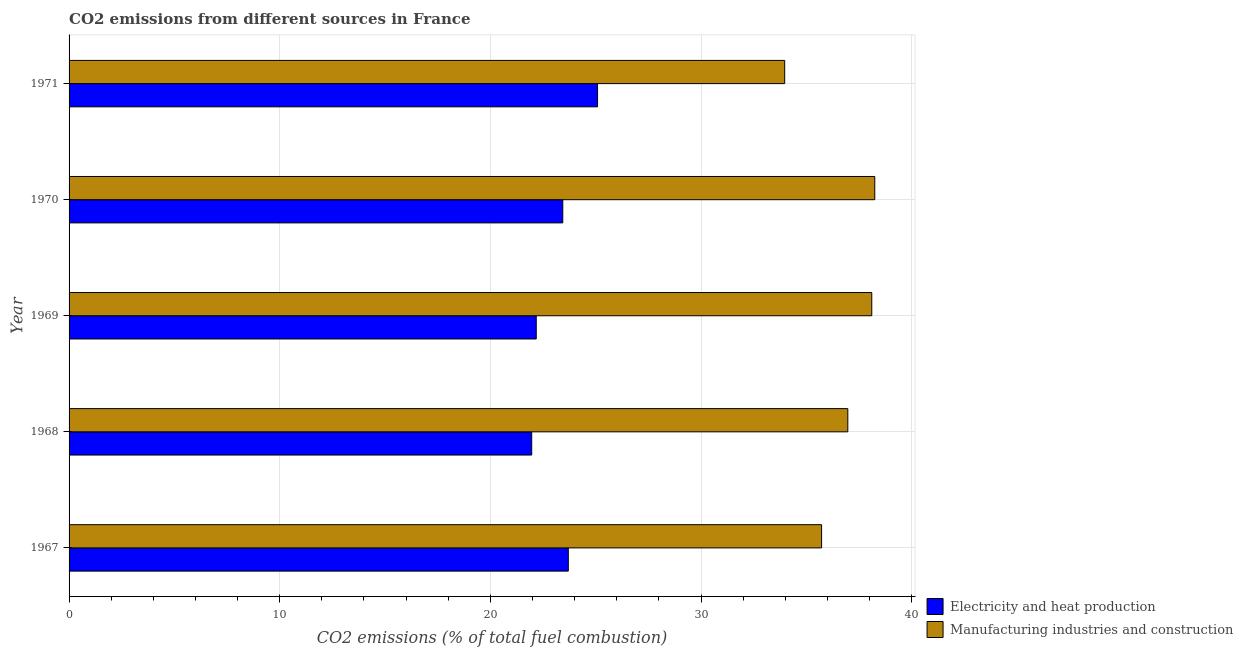How many different coloured bars are there?
Your response must be concise. 2. How many groups of bars are there?
Ensure brevity in your answer.  5. Are the number of bars on each tick of the Y-axis equal?
Your response must be concise. Yes. How many bars are there on the 2nd tick from the bottom?
Your answer should be very brief. 2. In how many cases, is the number of bars for a given year not equal to the number of legend labels?
Keep it short and to the point. 0. What is the co2 emissions due to manufacturing industries in 1969?
Make the answer very short. 38.1. Across all years, what is the maximum co2 emissions due to manufacturing industries?
Make the answer very short. 38.25. Across all years, what is the minimum co2 emissions due to manufacturing industries?
Ensure brevity in your answer.  33.97. In which year was the co2 emissions due to manufacturing industries maximum?
Offer a terse response. 1970. In which year was the co2 emissions due to electricity and heat production minimum?
Your answer should be compact. 1968. What is the total co2 emissions due to manufacturing industries in the graph?
Offer a very short reply. 183.02. What is the difference between the co2 emissions due to electricity and heat production in 1968 and that in 1970?
Keep it short and to the point. -1.48. What is the difference between the co2 emissions due to manufacturing industries in 1967 and the co2 emissions due to electricity and heat production in 1970?
Offer a very short reply. 12.29. What is the average co2 emissions due to manufacturing industries per year?
Offer a terse response. 36.6. In the year 1969, what is the difference between the co2 emissions due to manufacturing industries and co2 emissions due to electricity and heat production?
Your answer should be compact. 15.93. What is the ratio of the co2 emissions due to manufacturing industries in 1967 to that in 1971?
Keep it short and to the point. 1.05. Is the difference between the co2 emissions due to electricity and heat production in 1967 and 1969 greater than the difference between the co2 emissions due to manufacturing industries in 1967 and 1969?
Offer a very short reply. Yes. What is the difference between the highest and the second highest co2 emissions due to manufacturing industries?
Keep it short and to the point. 0.14. What is the difference between the highest and the lowest co2 emissions due to electricity and heat production?
Make the answer very short. 3.13. Is the sum of the co2 emissions due to manufacturing industries in 1968 and 1970 greater than the maximum co2 emissions due to electricity and heat production across all years?
Give a very brief answer. Yes. What does the 2nd bar from the top in 1970 represents?
Ensure brevity in your answer.  Electricity and heat production. What does the 1st bar from the bottom in 1967 represents?
Your answer should be compact. Electricity and heat production. What is the difference between two consecutive major ticks on the X-axis?
Make the answer very short. 10. Does the graph contain grids?
Provide a short and direct response. Yes. Where does the legend appear in the graph?
Make the answer very short. Bottom right. How many legend labels are there?
Offer a terse response. 2. How are the legend labels stacked?
Your answer should be very brief. Vertical. What is the title of the graph?
Your answer should be very brief. CO2 emissions from different sources in France. Does "RDB concessional" appear as one of the legend labels in the graph?
Offer a very short reply. No. What is the label or title of the X-axis?
Provide a succinct answer. CO2 emissions (% of total fuel combustion). What is the CO2 emissions (% of total fuel combustion) of Electricity and heat production in 1967?
Offer a terse response. 23.7. What is the CO2 emissions (% of total fuel combustion) in Manufacturing industries and construction in 1967?
Provide a succinct answer. 35.72. What is the CO2 emissions (% of total fuel combustion) of Electricity and heat production in 1968?
Provide a succinct answer. 21.96. What is the CO2 emissions (% of total fuel combustion) of Manufacturing industries and construction in 1968?
Your answer should be compact. 36.97. What is the CO2 emissions (% of total fuel combustion) of Electricity and heat production in 1969?
Provide a short and direct response. 22.18. What is the CO2 emissions (% of total fuel combustion) of Manufacturing industries and construction in 1969?
Offer a very short reply. 38.1. What is the CO2 emissions (% of total fuel combustion) in Electricity and heat production in 1970?
Provide a short and direct response. 23.44. What is the CO2 emissions (% of total fuel combustion) in Manufacturing industries and construction in 1970?
Your response must be concise. 38.25. What is the CO2 emissions (% of total fuel combustion) in Electricity and heat production in 1971?
Give a very brief answer. 25.09. What is the CO2 emissions (% of total fuel combustion) of Manufacturing industries and construction in 1971?
Provide a short and direct response. 33.97. Across all years, what is the maximum CO2 emissions (% of total fuel combustion) of Electricity and heat production?
Make the answer very short. 25.09. Across all years, what is the maximum CO2 emissions (% of total fuel combustion) of Manufacturing industries and construction?
Provide a short and direct response. 38.25. Across all years, what is the minimum CO2 emissions (% of total fuel combustion) of Electricity and heat production?
Offer a terse response. 21.96. Across all years, what is the minimum CO2 emissions (% of total fuel combustion) of Manufacturing industries and construction?
Your response must be concise. 33.97. What is the total CO2 emissions (% of total fuel combustion) of Electricity and heat production in the graph?
Provide a succinct answer. 116.36. What is the total CO2 emissions (% of total fuel combustion) of Manufacturing industries and construction in the graph?
Your answer should be compact. 183.02. What is the difference between the CO2 emissions (% of total fuel combustion) in Electricity and heat production in 1967 and that in 1968?
Offer a very short reply. 1.74. What is the difference between the CO2 emissions (% of total fuel combustion) of Manufacturing industries and construction in 1967 and that in 1968?
Your answer should be compact. -1.24. What is the difference between the CO2 emissions (% of total fuel combustion) of Electricity and heat production in 1967 and that in 1969?
Give a very brief answer. 1.52. What is the difference between the CO2 emissions (% of total fuel combustion) of Manufacturing industries and construction in 1967 and that in 1969?
Your answer should be very brief. -2.38. What is the difference between the CO2 emissions (% of total fuel combustion) in Electricity and heat production in 1967 and that in 1970?
Give a very brief answer. 0.26. What is the difference between the CO2 emissions (% of total fuel combustion) of Manufacturing industries and construction in 1967 and that in 1970?
Give a very brief answer. -2.52. What is the difference between the CO2 emissions (% of total fuel combustion) of Electricity and heat production in 1967 and that in 1971?
Provide a short and direct response. -1.39. What is the difference between the CO2 emissions (% of total fuel combustion) of Manufacturing industries and construction in 1967 and that in 1971?
Keep it short and to the point. 1.75. What is the difference between the CO2 emissions (% of total fuel combustion) in Electricity and heat production in 1968 and that in 1969?
Make the answer very short. -0.22. What is the difference between the CO2 emissions (% of total fuel combustion) of Manufacturing industries and construction in 1968 and that in 1969?
Your answer should be very brief. -1.14. What is the difference between the CO2 emissions (% of total fuel combustion) in Electricity and heat production in 1968 and that in 1970?
Provide a succinct answer. -1.48. What is the difference between the CO2 emissions (% of total fuel combustion) of Manufacturing industries and construction in 1968 and that in 1970?
Provide a succinct answer. -1.28. What is the difference between the CO2 emissions (% of total fuel combustion) of Electricity and heat production in 1968 and that in 1971?
Make the answer very short. -3.13. What is the difference between the CO2 emissions (% of total fuel combustion) of Manufacturing industries and construction in 1968 and that in 1971?
Give a very brief answer. 3. What is the difference between the CO2 emissions (% of total fuel combustion) in Electricity and heat production in 1969 and that in 1970?
Offer a very short reply. -1.26. What is the difference between the CO2 emissions (% of total fuel combustion) in Manufacturing industries and construction in 1969 and that in 1970?
Provide a short and direct response. -0.14. What is the difference between the CO2 emissions (% of total fuel combustion) of Electricity and heat production in 1969 and that in 1971?
Offer a terse response. -2.91. What is the difference between the CO2 emissions (% of total fuel combustion) in Manufacturing industries and construction in 1969 and that in 1971?
Keep it short and to the point. 4.13. What is the difference between the CO2 emissions (% of total fuel combustion) in Electricity and heat production in 1970 and that in 1971?
Your answer should be very brief. -1.65. What is the difference between the CO2 emissions (% of total fuel combustion) of Manufacturing industries and construction in 1970 and that in 1971?
Your answer should be compact. 4.28. What is the difference between the CO2 emissions (% of total fuel combustion) in Electricity and heat production in 1967 and the CO2 emissions (% of total fuel combustion) in Manufacturing industries and construction in 1968?
Offer a terse response. -13.27. What is the difference between the CO2 emissions (% of total fuel combustion) in Electricity and heat production in 1967 and the CO2 emissions (% of total fuel combustion) in Manufacturing industries and construction in 1969?
Ensure brevity in your answer.  -14.41. What is the difference between the CO2 emissions (% of total fuel combustion) in Electricity and heat production in 1967 and the CO2 emissions (% of total fuel combustion) in Manufacturing industries and construction in 1970?
Offer a terse response. -14.55. What is the difference between the CO2 emissions (% of total fuel combustion) of Electricity and heat production in 1967 and the CO2 emissions (% of total fuel combustion) of Manufacturing industries and construction in 1971?
Provide a succinct answer. -10.27. What is the difference between the CO2 emissions (% of total fuel combustion) in Electricity and heat production in 1968 and the CO2 emissions (% of total fuel combustion) in Manufacturing industries and construction in 1969?
Give a very brief answer. -16.14. What is the difference between the CO2 emissions (% of total fuel combustion) in Electricity and heat production in 1968 and the CO2 emissions (% of total fuel combustion) in Manufacturing industries and construction in 1970?
Provide a short and direct response. -16.29. What is the difference between the CO2 emissions (% of total fuel combustion) of Electricity and heat production in 1968 and the CO2 emissions (% of total fuel combustion) of Manufacturing industries and construction in 1971?
Make the answer very short. -12.01. What is the difference between the CO2 emissions (% of total fuel combustion) of Electricity and heat production in 1969 and the CO2 emissions (% of total fuel combustion) of Manufacturing industries and construction in 1970?
Keep it short and to the point. -16.07. What is the difference between the CO2 emissions (% of total fuel combustion) in Electricity and heat production in 1969 and the CO2 emissions (% of total fuel combustion) in Manufacturing industries and construction in 1971?
Provide a succinct answer. -11.79. What is the difference between the CO2 emissions (% of total fuel combustion) of Electricity and heat production in 1970 and the CO2 emissions (% of total fuel combustion) of Manufacturing industries and construction in 1971?
Your answer should be very brief. -10.53. What is the average CO2 emissions (% of total fuel combustion) of Electricity and heat production per year?
Ensure brevity in your answer.  23.27. What is the average CO2 emissions (% of total fuel combustion) in Manufacturing industries and construction per year?
Provide a succinct answer. 36.6. In the year 1967, what is the difference between the CO2 emissions (% of total fuel combustion) in Electricity and heat production and CO2 emissions (% of total fuel combustion) in Manufacturing industries and construction?
Ensure brevity in your answer.  -12.02. In the year 1968, what is the difference between the CO2 emissions (% of total fuel combustion) in Electricity and heat production and CO2 emissions (% of total fuel combustion) in Manufacturing industries and construction?
Offer a very short reply. -15.01. In the year 1969, what is the difference between the CO2 emissions (% of total fuel combustion) of Electricity and heat production and CO2 emissions (% of total fuel combustion) of Manufacturing industries and construction?
Offer a very short reply. -15.93. In the year 1970, what is the difference between the CO2 emissions (% of total fuel combustion) of Electricity and heat production and CO2 emissions (% of total fuel combustion) of Manufacturing industries and construction?
Provide a short and direct response. -14.81. In the year 1971, what is the difference between the CO2 emissions (% of total fuel combustion) in Electricity and heat production and CO2 emissions (% of total fuel combustion) in Manufacturing industries and construction?
Your answer should be compact. -8.88. What is the ratio of the CO2 emissions (% of total fuel combustion) in Electricity and heat production in 1967 to that in 1968?
Offer a terse response. 1.08. What is the ratio of the CO2 emissions (% of total fuel combustion) in Manufacturing industries and construction in 1967 to that in 1968?
Offer a very short reply. 0.97. What is the ratio of the CO2 emissions (% of total fuel combustion) of Electricity and heat production in 1967 to that in 1969?
Give a very brief answer. 1.07. What is the ratio of the CO2 emissions (% of total fuel combustion) of Electricity and heat production in 1967 to that in 1970?
Make the answer very short. 1.01. What is the ratio of the CO2 emissions (% of total fuel combustion) in Manufacturing industries and construction in 1967 to that in 1970?
Your response must be concise. 0.93. What is the ratio of the CO2 emissions (% of total fuel combustion) in Electricity and heat production in 1967 to that in 1971?
Provide a short and direct response. 0.94. What is the ratio of the CO2 emissions (% of total fuel combustion) in Manufacturing industries and construction in 1967 to that in 1971?
Give a very brief answer. 1.05. What is the ratio of the CO2 emissions (% of total fuel combustion) of Electricity and heat production in 1968 to that in 1969?
Offer a very short reply. 0.99. What is the ratio of the CO2 emissions (% of total fuel combustion) in Manufacturing industries and construction in 1968 to that in 1969?
Offer a terse response. 0.97. What is the ratio of the CO2 emissions (% of total fuel combustion) in Electricity and heat production in 1968 to that in 1970?
Ensure brevity in your answer.  0.94. What is the ratio of the CO2 emissions (% of total fuel combustion) in Manufacturing industries and construction in 1968 to that in 1970?
Your response must be concise. 0.97. What is the ratio of the CO2 emissions (% of total fuel combustion) in Electricity and heat production in 1968 to that in 1971?
Provide a succinct answer. 0.88. What is the ratio of the CO2 emissions (% of total fuel combustion) in Manufacturing industries and construction in 1968 to that in 1971?
Ensure brevity in your answer.  1.09. What is the ratio of the CO2 emissions (% of total fuel combustion) of Electricity and heat production in 1969 to that in 1970?
Keep it short and to the point. 0.95. What is the ratio of the CO2 emissions (% of total fuel combustion) in Electricity and heat production in 1969 to that in 1971?
Keep it short and to the point. 0.88. What is the ratio of the CO2 emissions (% of total fuel combustion) in Manufacturing industries and construction in 1969 to that in 1971?
Provide a short and direct response. 1.12. What is the ratio of the CO2 emissions (% of total fuel combustion) of Electricity and heat production in 1970 to that in 1971?
Offer a terse response. 0.93. What is the ratio of the CO2 emissions (% of total fuel combustion) in Manufacturing industries and construction in 1970 to that in 1971?
Your answer should be compact. 1.13. What is the difference between the highest and the second highest CO2 emissions (% of total fuel combustion) in Electricity and heat production?
Ensure brevity in your answer.  1.39. What is the difference between the highest and the second highest CO2 emissions (% of total fuel combustion) in Manufacturing industries and construction?
Your answer should be compact. 0.14. What is the difference between the highest and the lowest CO2 emissions (% of total fuel combustion) in Electricity and heat production?
Your answer should be very brief. 3.13. What is the difference between the highest and the lowest CO2 emissions (% of total fuel combustion) in Manufacturing industries and construction?
Your response must be concise. 4.28. 